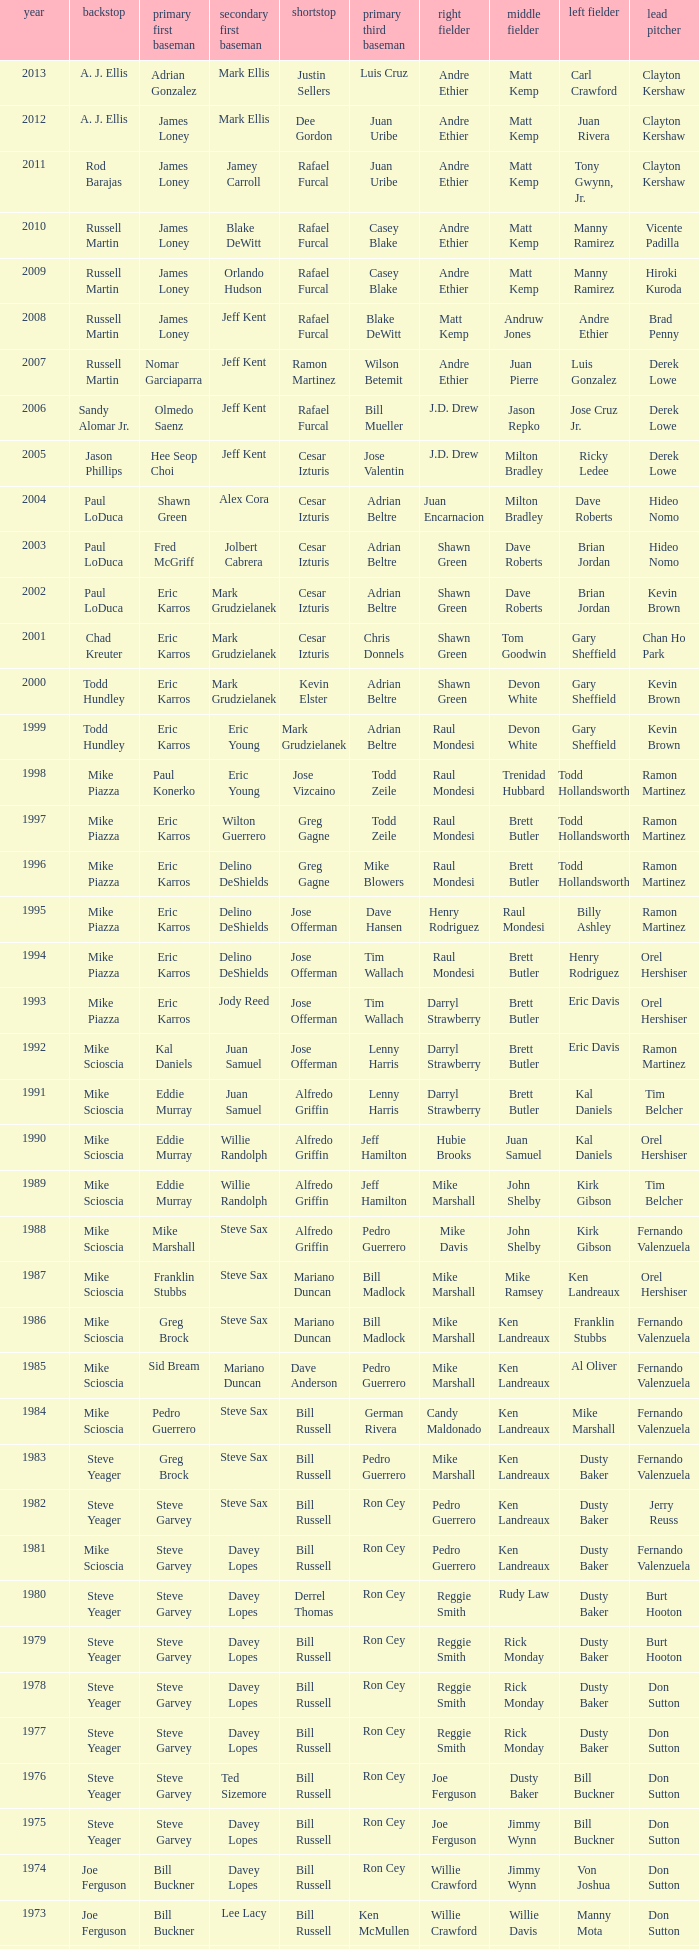Who was the SS when jim lefebvre was at 2nd, willie davis at CF, and don drysdale was the SP. Maury Wills. 